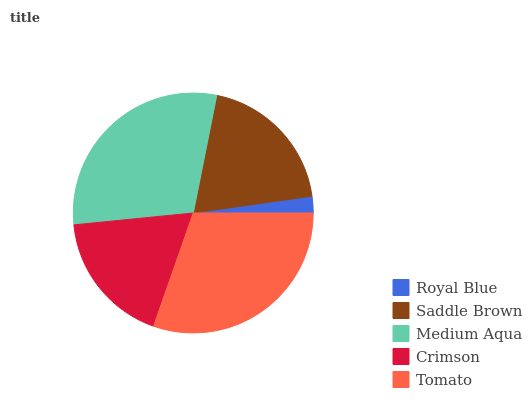Is Royal Blue the minimum?
Answer yes or no. Yes. Is Tomato the maximum?
Answer yes or no. Yes. Is Saddle Brown the minimum?
Answer yes or no. No. Is Saddle Brown the maximum?
Answer yes or no. No. Is Saddle Brown greater than Royal Blue?
Answer yes or no. Yes. Is Royal Blue less than Saddle Brown?
Answer yes or no. Yes. Is Royal Blue greater than Saddle Brown?
Answer yes or no. No. Is Saddle Brown less than Royal Blue?
Answer yes or no. No. Is Saddle Brown the high median?
Answer yes or no. Yes. Is Saddle Brown the low median?
Answer yes or no. Yes. Is Royal Blue the high median?
Answer yes or no. No. Is Crimson the low median?
Answer yes or no. No. 